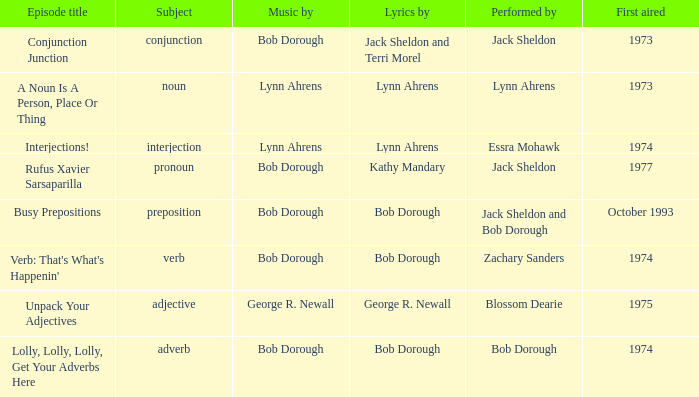When pronoun is the subject what is the episode title? Rufus Xavier Sarsaparilla. 